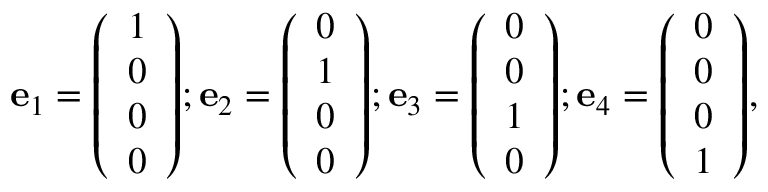Convert formula to latex. <formula><loc_0><loc_0><loc_500><loc_500>e _ { 1 } = { \left ( \begin{array} { l } { 1 } \\ { 0 } \\ { 0 } \\ { 0 } \end{array} \right ) } ; e _ { 2 } = { \left ( \begin{array} { l } { 0 } \\ { 1 } \\ { 0 } \\ { 0 } \end{array} \right ) } ; e _ { 3 } = { \left ( \begin{array} { l } { 0 } \\ { 0 } \\ { 1 } \\ { 0 } \end{array} \right ) } ; e _ { 4 } = { \left ( \begin{array} { l } { 0 } \\ { 0 } \\ { 0 } \\ { 1 } \end{array} \right ) } ,</formula> 